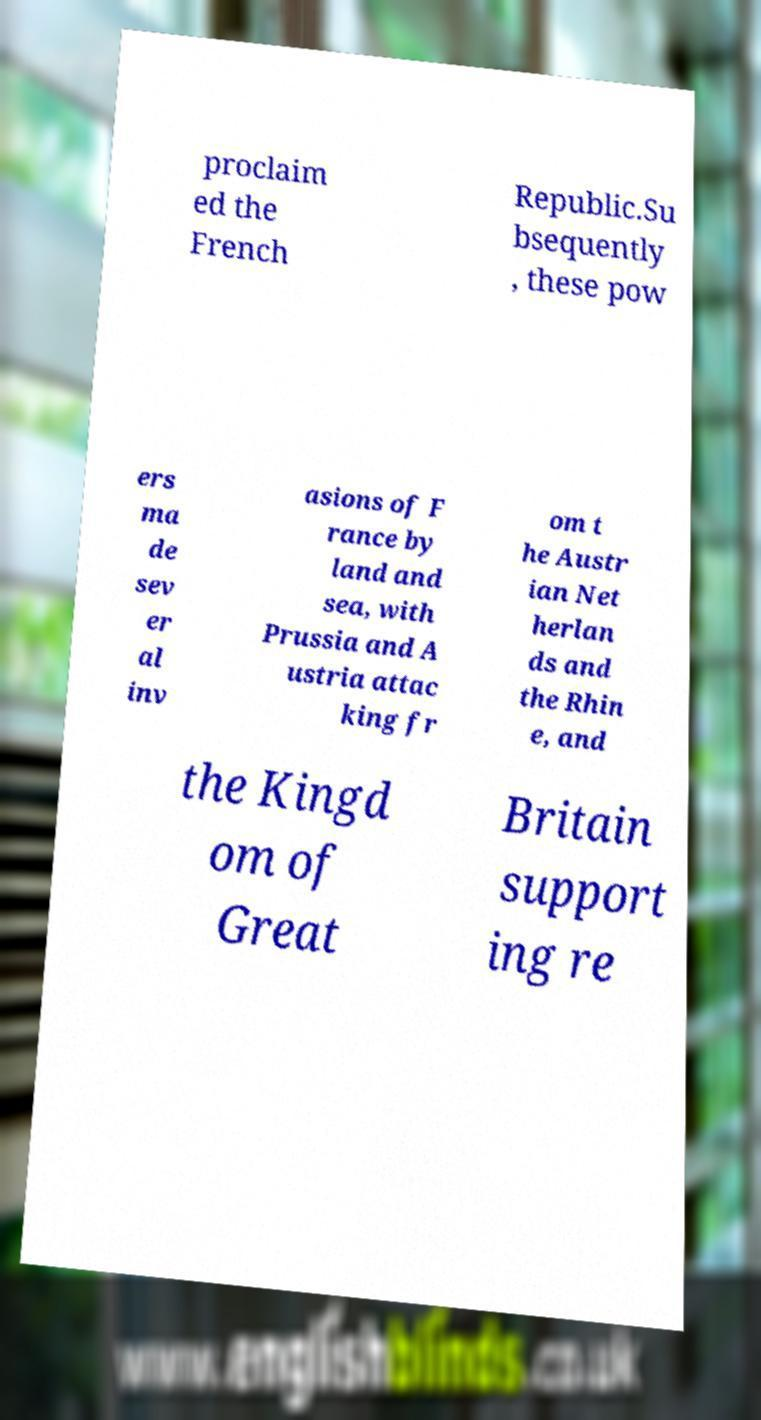Please read and relay the text visible in this image. What does it say? proclaim ed the French Republic.Su bsequently , these pow ers ma de sev er al inv asions of F rance by land and sea, with Prussia and A ustria attac king fr om t he Austr ian Net herlan ds and the Rhin e, and the Kingd om of Great Britain support ing re 